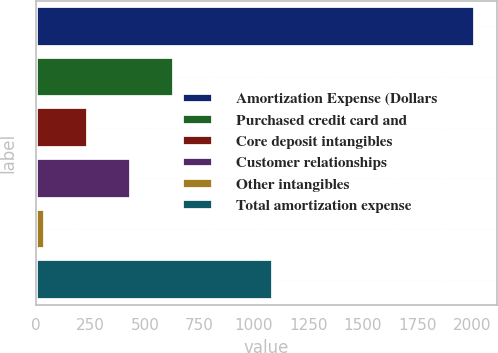<chart> <loc_0><loc_0><loc_500><loc_500><bar_chart><fcel>Amortization Expense (Dollars<fcel>Purchased credit card and<fcel>Core deposit intangibles<fcel>Customer relationships<fcel>Other intangibles<fcel>Total amortization expense<nl><fcel>2013<fcel>634<fcel>240<fcel>437<fcel>43<fcel>1086<nl></chart> 